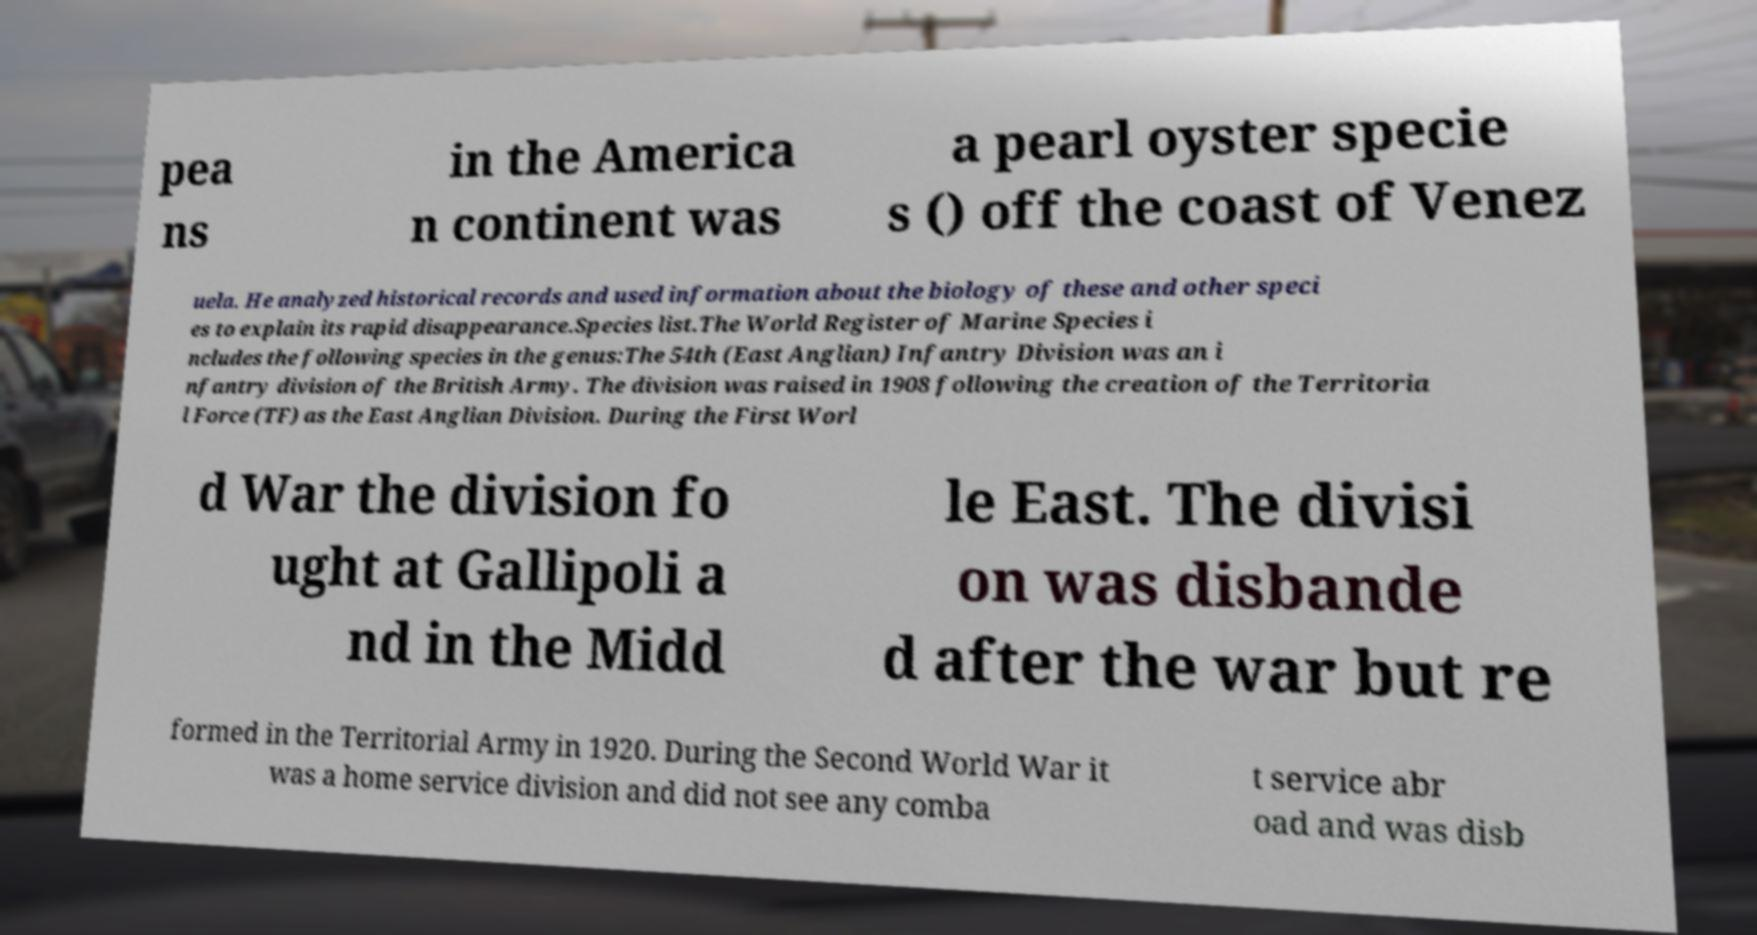Can you accurately transcribe the text from the provided image for me? pea ns in the America n continent was a pearl oyster specie s () off the coast of Venez uela. He analyzed historical records and used information about the biology of these and other speci es to explain its rapid disappearance.Species list.The World Register of Marine Species i ncludes the following species in the genus:The 54th (East Anglian) Infantry Division was an i nfantry division of the British Army. The division was raised in 1908 following the creation of the Territoria l Force (TF) as the East Anglian Division. During the First Worl d War the division fo ught at Gallipoli a nd in the Midd le East. The divisi on was disbande d after the war but re formed in the Territorial Army in 1920. During the Second World War it was a home service division and did not see any comba t service abr oad and was disb 